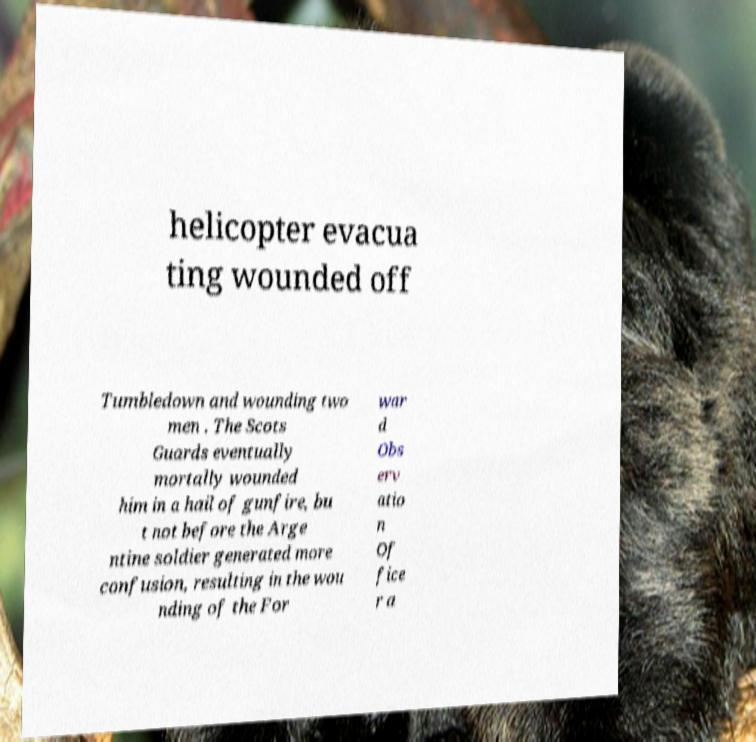Could you assist in decoding the text presented in this image and type it out clearly? helicopter evacua ting wounded off Tumbledown and wounding two men . The Scots Guards eventually mortally wounded him in a hail of gunfire, bu t not before the Arge ntine soldier generated more confusion, resulting in the wou nding of the For war d Obs erv atio n Of fice r a 